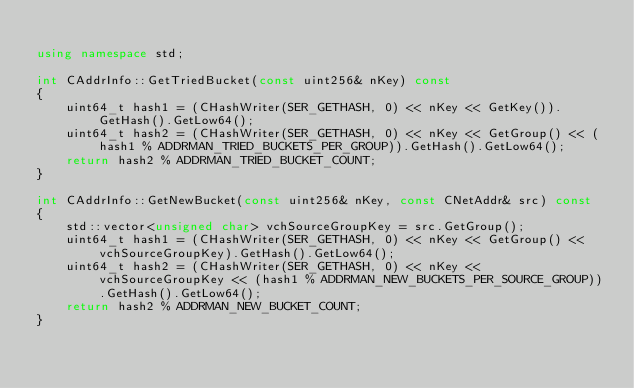<code> <loc_0><loc_0><loc_500><loc_500><_C++_>
using namespace std;

int CAddrInfo::GetTriedBucket(const uint256& nKey) const
{
    uint64_t hash1 = (CHashWriter(SER_GETHASH, 0) << nKey << GetKey()).GetHash().GetLow64();
    uint64_t hash2 = (CHashWriter(SER_GETHASH, 0) << nKey << GetGroup() << (hash1 % ADDRMAN_TRIED_BUCKETS_PER_GROUP)).GetHash().GetLow64();
    return hash2 % ADDRMAN_TRIED_BUCKET_COUNT;
}

int CAddrInfo::GetNewBucket(const uint256& nKey, const CNetAddr& src) const
{
    std::vector<unsigned char> vchSourceGroupKey = src.GetGroup();
    uint64_t hash1 = (CHashWriter(SER_GETHASH, 0) << nKey << GetGroup() << vchSourceGroupKey).GetHash().GetLow64();
    uint64_t hash2 = (CHashWriter(SER_GETHASH, 0) << nKey << vchSourceGroupKey << (hash1 % ADDRMAN_NEW_BUCKETS_PER_SOURCE_GROUP)).GetHash().GetLow64();
    return hash2 % ADDRMAN_NEW_BUCKET_COUNT;
}
</code> 